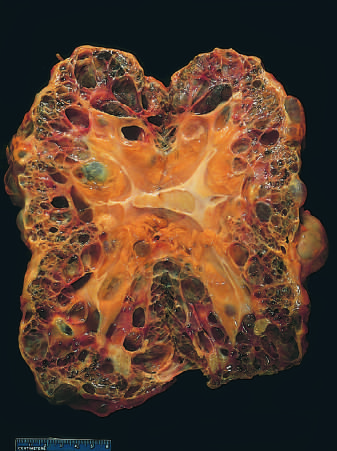s remote kidney infarct markedly enlarged?
Answer the question using a single word or phrase. No 